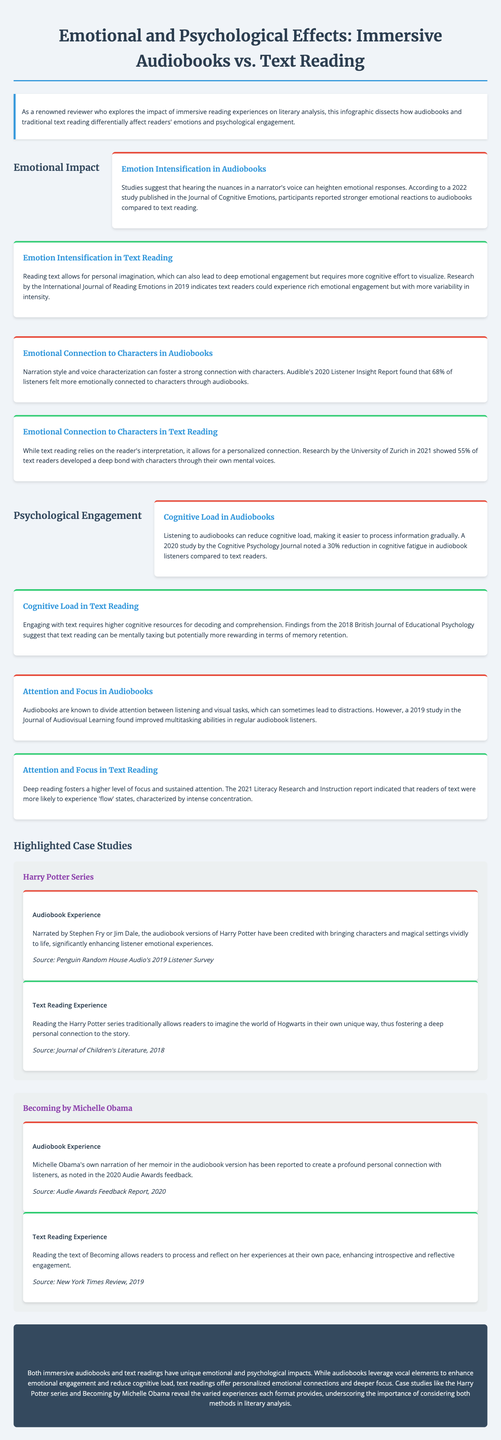What year was the study published that compared emotional responses to audiobooks? The study was published in 2022 in the Journal of Cognitive Emotions.
Answer: 2022 What percentage of audiobook listeners felt more emotionally connected to characters? According to Audible's report, 68% of listeners felt more connected through audiobooks.
Answer: 68% Which reading format allows for a personalized emotional connection according to the text? Text reading allows for a personalized connection through the reader's interpretation.
Answer: Text reading How much cognitive fatigue was noted to decrease in audiobook listeners? A study indicated a 30% reduction in cognitive fatigue in audiobook listeners.
Answer: 30% Which author narrated their own audiobook in the highlighted case study? Michelle Obama narrated her own memoir in the audiobook version.
Answer: Michelle Obama In which report was the emotional engagement of text reading described? The emotional engagement of text reading was described in the International Journal of Reading Emotions in 2019.
Answer: International Journal of Reading Emotions What key benefit does text reading provide compared to audiobooks regarding focus? Text reading fosters a higher level of focus and sustained attention.
Answer: Higher focus What term describes the state experienced by readers of text according to the 2021 report? The term used is 'flow' states, characterized by intense concentration.
Answer: 'Flow' states Which series is cited as a case study for audiobook experience in the infographic? The Harry Potter series is cited as a case study for audiobook experience.
Answer: Harry Potter series 